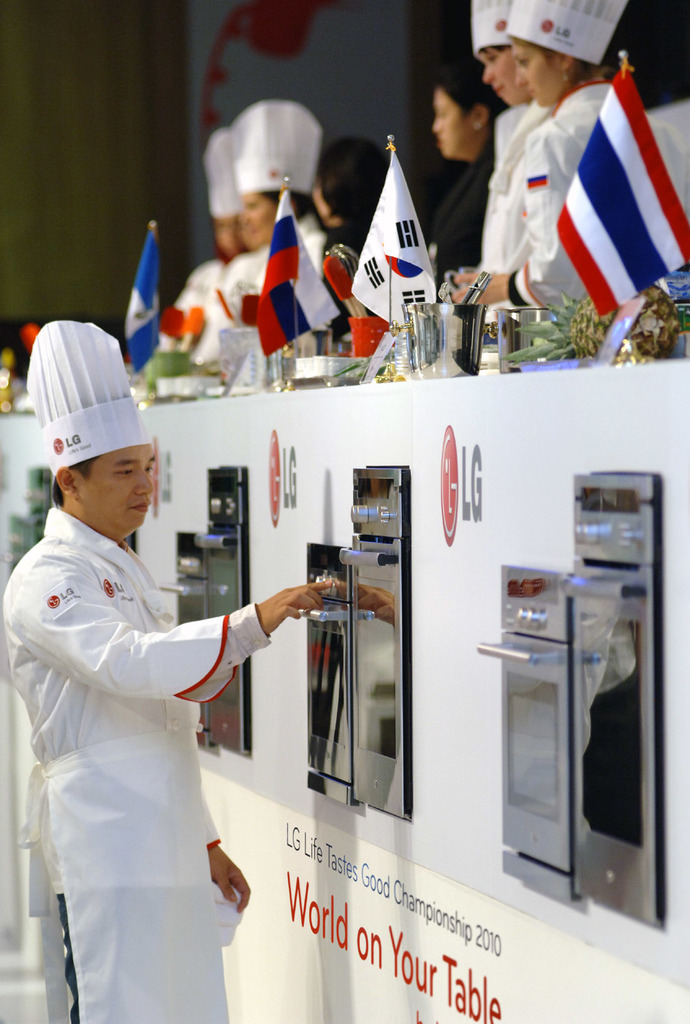Describe the setting and atmosphere of this event as shown in the image. The event is set up with modern cooking stations equipped with advanced kitchen appliances, reflecting a professional and competitive atmosphere. The participants are focused and dedicated, contributing to a dynamic and energetic environment. What might be the impact of such competitions on the participants and audience? Competitions like these can greatly impact participants by enhancing their culinary skills, reputation, and network. For the audience, it offers an insight into diverse culinary arts and fosters a greater appreciation for different food cultures. 